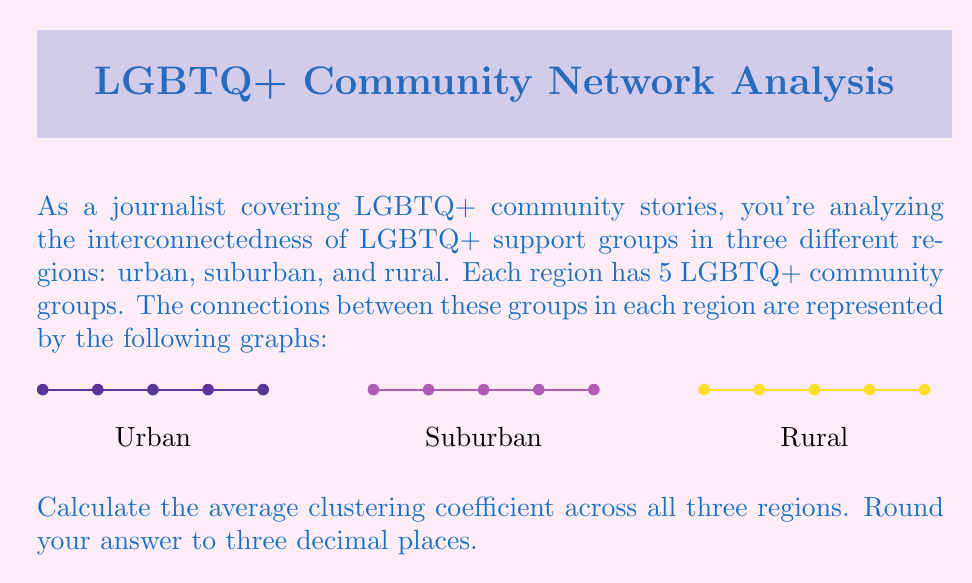Give your solution to this math problem. To solve this problem, we need to follow these steps:

1) Calculate the clustering coefficient for each region.
2) Take the average of these three coefficients.

The clustering coefficient for a node is calculated as:

$C_i = \frac{2 \times e_i}{k_i(k_i-1)}$

Where $e_i$ is the number of edges between the neighbors of node $i$, and $k_i$ is the number of neighbors of node $i$.

For a graph, we take the average of all node clustering coefficients.

Let's calculate for each region:

1) Urban region:
   All nodes are connected to each other, so for each node:
   $k_i = 4$, $e_i = 6$
   $C_i = \frac{2 \times 6}{4(4-1)} = 1$
   Average clustering coefficient for urban region = 1

2) Suburban region:
   For each node: $k_i = 3$, $e_i = 1$
   $C_i = \frac{2 \times 1}{3(3-1)} = \frac{1}{3}$
   Average clustering coefficient for suburban region = $\frac{1}{3}$

3) Rural region:
   For end nodes (2): $k_i = 1$, clustering coefficient undefined
   For middle nodes (3): $k_i = 2$, $e_i = 0$
   $C_i = \frac{2 \times 0}{2(2-1)} = 0$
   Average clustering coefficient for rural region = 0

Now, we take the average of these three coefficients:

$\text{Average} = \frac{1 + \frac{1}{3} + 0}{3} = \frac{4}{9} \approx 0.444$

Rounding to three decimal places, we get 0.444.
Answer: 0.444 